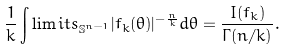Convert formula to latex. <formula><loc_0><loc_0><loc_500><loc_500>\frac { 1 } { k } \int \lim i t s _ { \mathbb { S } ^ { n - 1 } } | f _ { k } ( \theta ) | ^ { - \frac { n } { k } } d \theta = \frac { I ( f _ { k } ) } { \Gamma ( n / k ) } .</formula> 